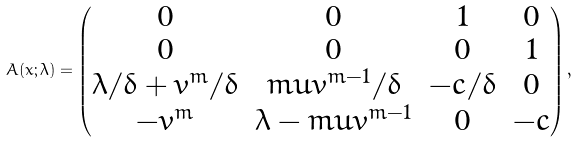<formula> <loc_0><loc_0><loc_500><loc_500>A ( x ; \lambda ) = \left ( \begin{matrix} 0 & 0 & 1 & 0 \\ 0 & 0 & 0 & 1 \\ \lambda / \delta + \bar { v } ^ { m } / \delta & m \bar { u } \bar { v } ^ { m - 1 } / \delta & - c / \delta & 0 \\ - \bar { v } ^ { m } & \lambda - m \bar { u } \bar { v } ^ { m - 1 } & 0 & - c \end{matrix} \right ) ,</formula> 